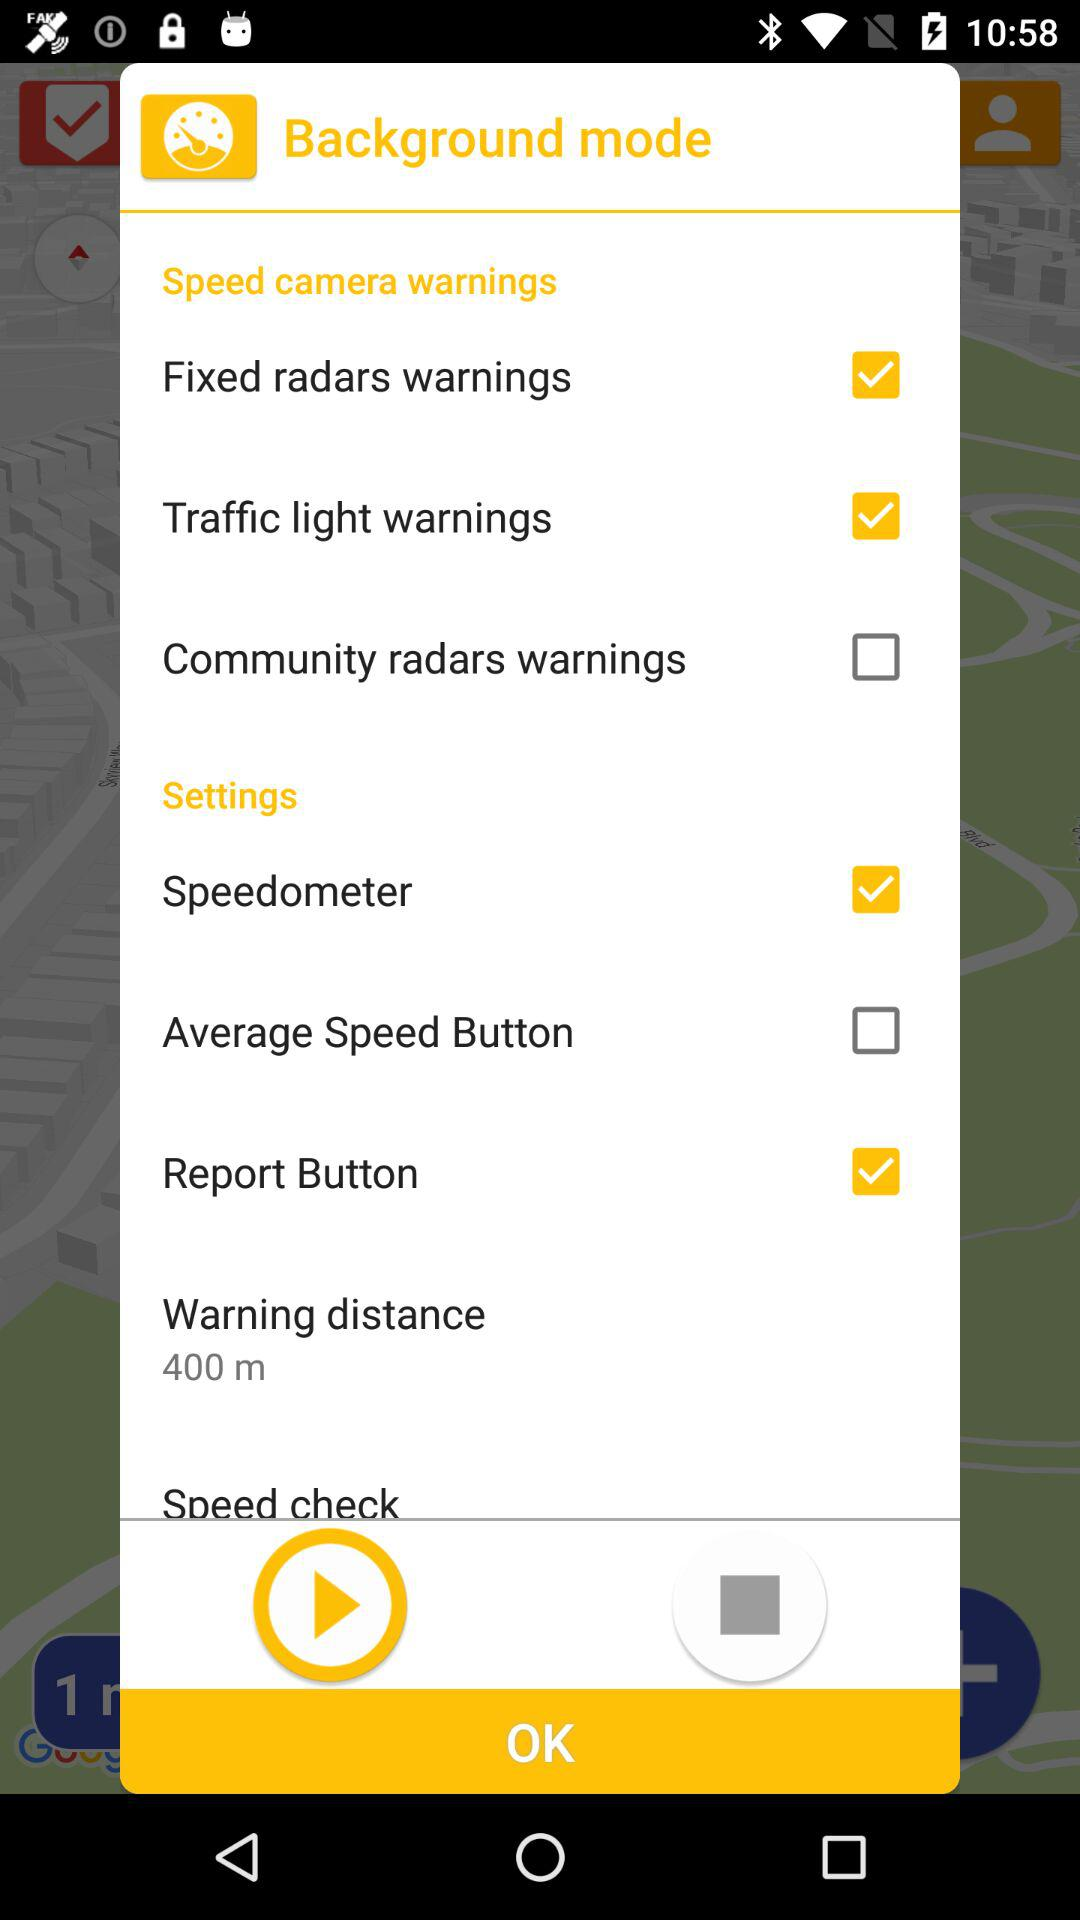Which options are selected in "Speed camera warnings"? In the 'Speed camera warnings' section, three options are selected: 'Fixed radars warnings,' 'Traffic light warnings,' and also 'Speedometer' located under the 'Settings' section. These features are likely designed to alert the user of various types of traffic monitoring systems and provide speed-related information to encourage safe driving habits. 